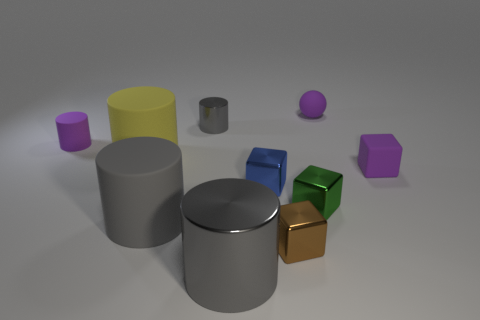Are there any rubber things?
Your answer should be very brief. Yes. Is the number of small matte spheres less than the number of yellow metal blocks?
Provide a succinct answer. No. Are there any brown objects that have the same size as the purple cylinder?
Offer a terse response. Yes. There is a big yellow rubber object; does it have the same shape as the large rubber object in front of the purple rubber cube?
Keep it short and to the point. Yes. How many blocks are small purple things or gray objects?
Offer a very short reply. 1. The small ball is what color?
Your answer should be compact. Purple. Is the number of blue cubes greater than the number of small objects?
Your answer should be very brief. No. What number of objects are either tiny matte things to the right of the gray rubber object or tiny cyan spheres?
Offer a very short reply. 2. Is the material of the small purple cylinder the same as the yellow object?
Keep it short and to the point. Yes. There is a purple thing that is the same shape as the tiny green object; what size is it?
Offer a very short reply. Small. 